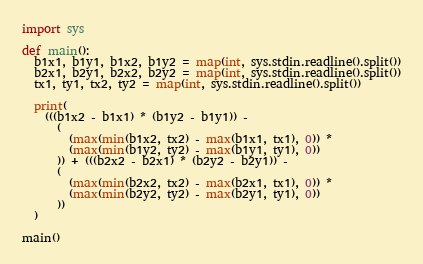Convert code to text. <code><loc_0><loc_0><loc_500><loc_500><_Python_>import sys

def main():
  b1x1, b1y1, b1x2, b1y2 = map(int, sys.stdin.readline().split())
  b2x1, b2y1, b2x2, b2y2 = map(int, sys.stdin.readline().split())
  tx1, ty1, tx2, ty2 = map(int, sys.stdin.readline().split())

  print(
    (((b1x2 - b1x1) * (b1y2 - b1y1)) -
      (
        (max(min(b1x2, tx2) - max(b1x1, tx1), 0)) *
        (max(min(b1y2, ty2) - max(b1y1, ty1), 0))
      )) + (((b2x2 - b2x1) * (b2y2 - b2y1)) -
      (
        (max(min(b2x2, tx2) - max(b2x1, tx1), 0)) *
        (max(min(b2y2, ty2) - max(b2y1, ty1), 0))
      ))
  )

main()
</code> 